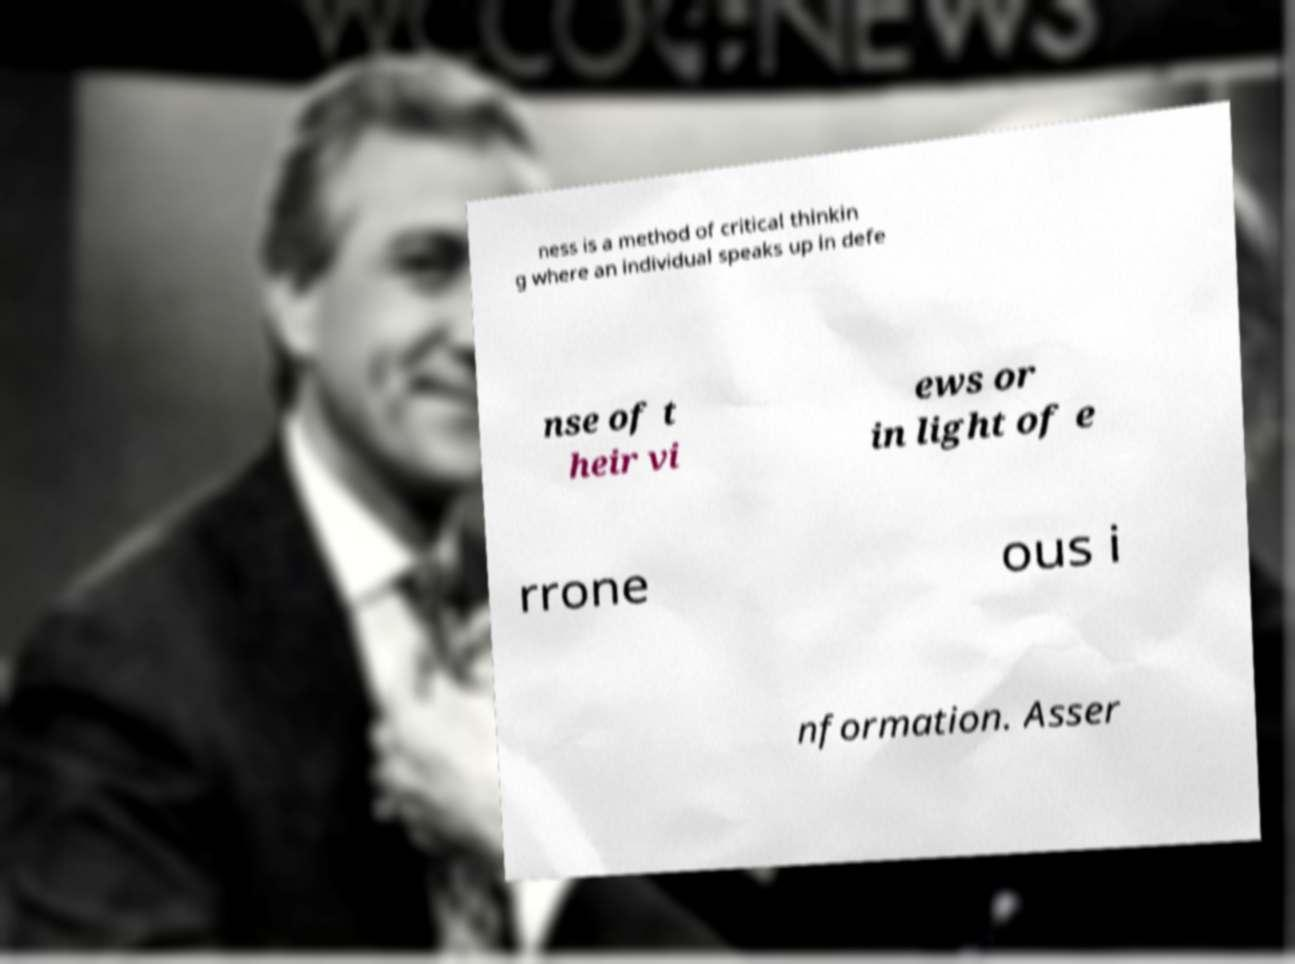Could you assist in decoding the text presented in this image and type it out clearly? ness is a method of critical thinkin g where an individual speaks up in defe nse of t heir vi ews or in light of e rrone ous i nformation. Asser 